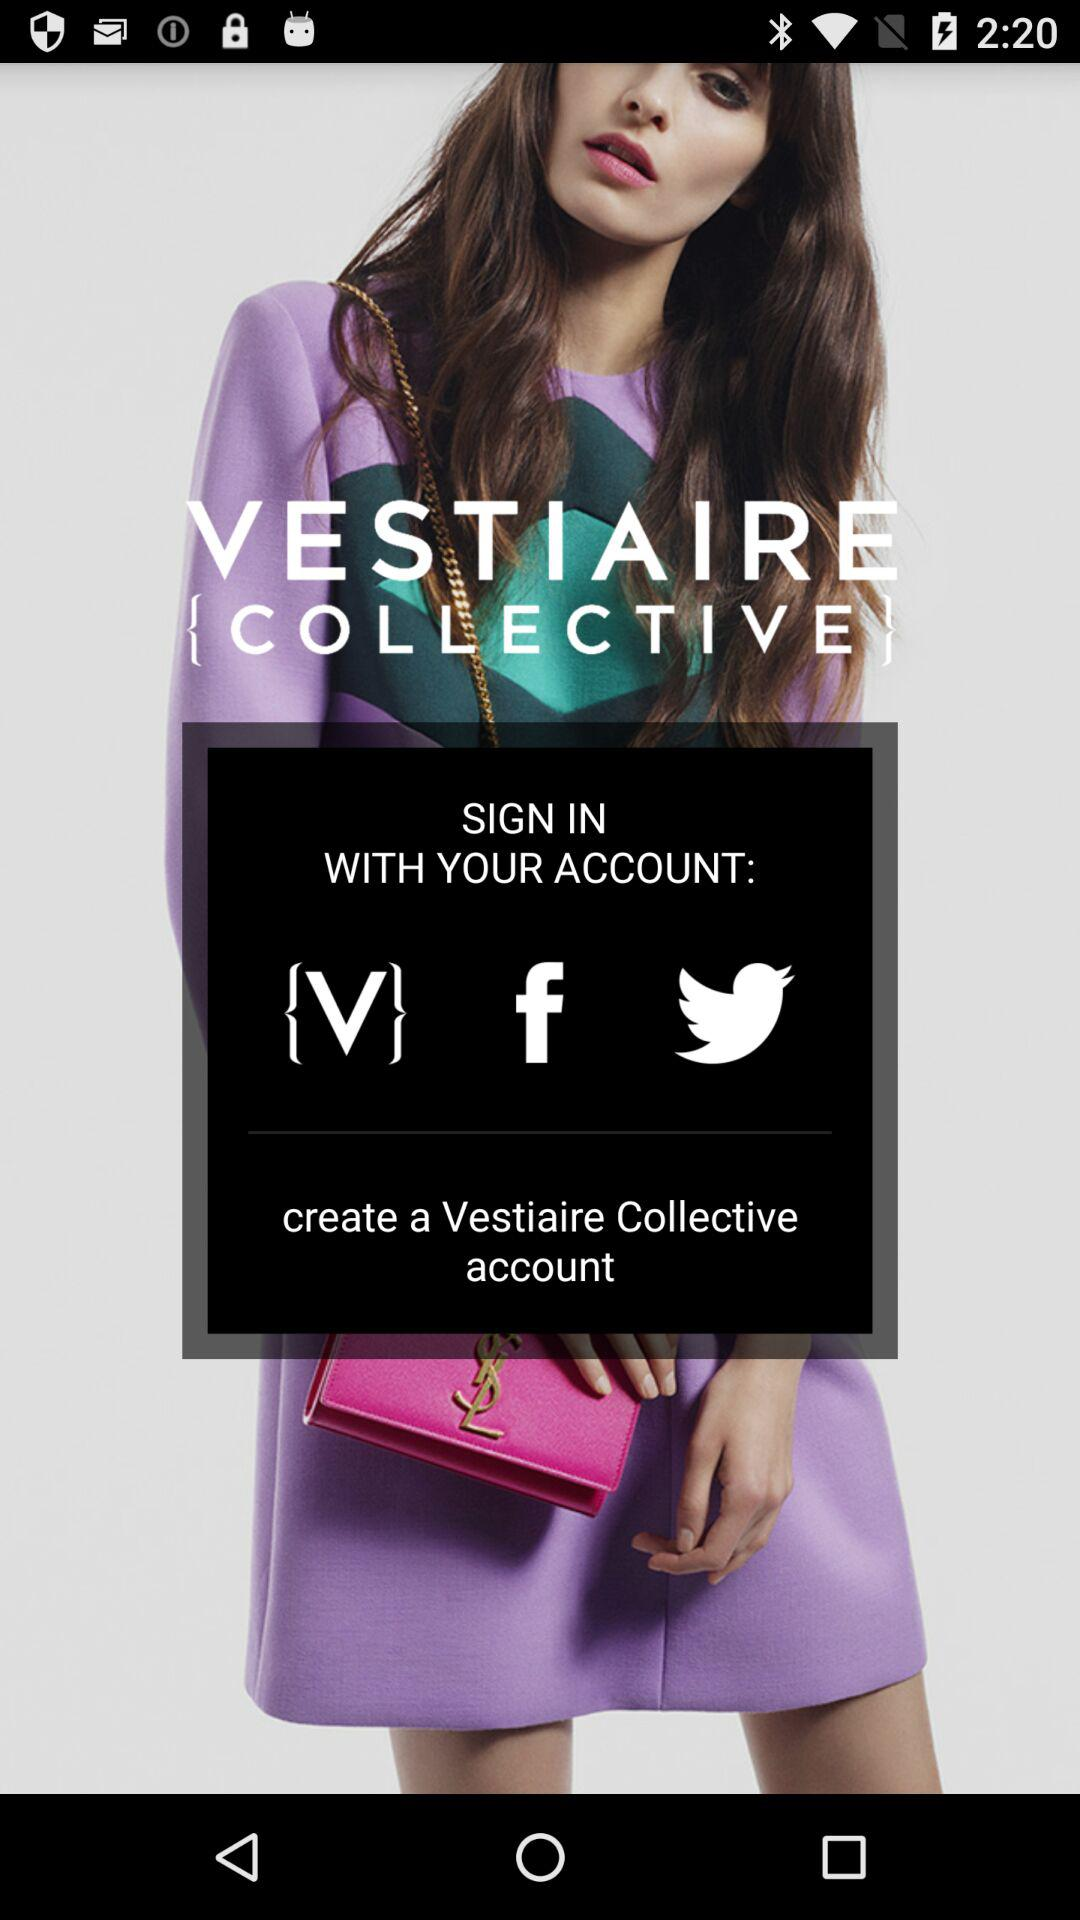Which apps can we use to sign in? You can use "Vestiaire", "Facebook" and "Twitter" to sign in. 